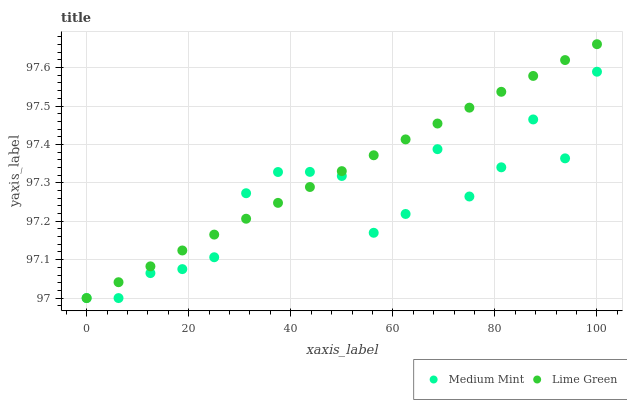Does Medium Mint have the minimum area under the curve?
Answer yes or no. Yes. Does Lime Green have the maximum area under the curve?
Answer yes or no. Yes. Does Lime Green have the minimum area under the curve?
Answer yes or no. No. Is Lime Green the smoothest?
Answer yes or no. Yes. Is Medium Mint the roughest?
Answer yes or no. Yes. Is Lime Green the roughest?
Answer yes or no. No. Does Medium Mint have the lowest value?
Answer yes or no. Yes. Does Lime Green have the highest value?
Answer yes or no. Yes. Does Lime Green intersect Medium Mint?
Answer yes or no. Yes. Is Lime Green less than Medium Mint?
Answer yes or no. No. Is Lime Green greater than Medium Mint?
Answer yes or no. No. 